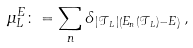Convert formula to latex. <formula><loc_0><loc_0><loc_500><loc_500>\mu _ { L } ^ { E } \colon = \sum _ { n } \delta _ { \, | \mathcal { T } _ { L } | \left ( E _ { n } ( \mathcal { T } _ { L } ) - E \right ) } \, ,</formula> 